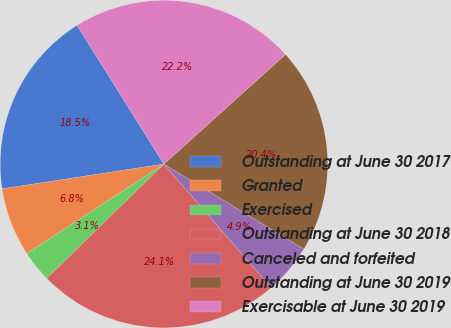<chart> <loc_0><loc_0><loc_500><loc_500><pie_chart><fcel>Outstanding at June 30 2017<fcel>Granted<fcel>Exercised<fcel>Outstanding at June 30 2018<fcel>Canceled and forfeited<fcel>Outstanding at June 30 2019<fcel>Exercisable at June 30 2019<nl><fcel>18.52%<fcel>6.79%<fcel>3.09%<fcel>24.07%<fcel>4.94%<fcel>20.37%<fcel>22.22%<nl></chart> 